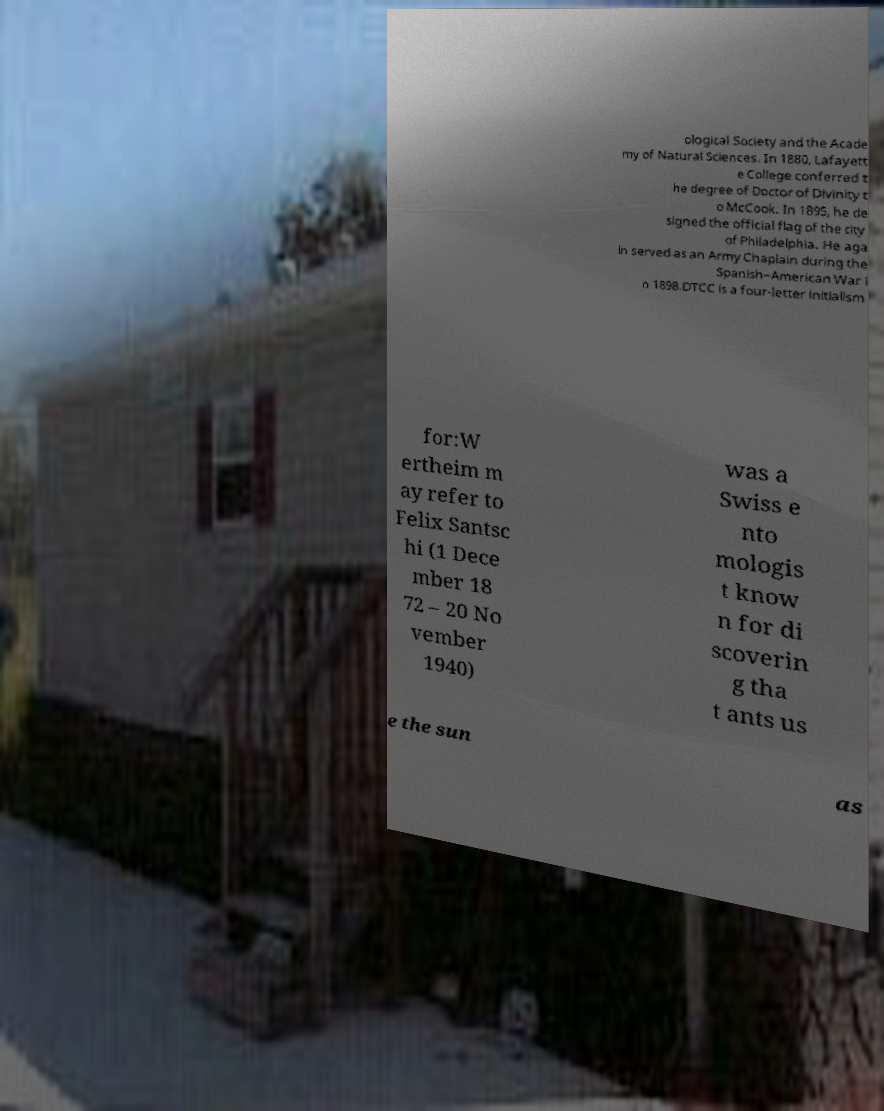Can you read and provide the text displayed in the image?This photo seems to have some interesting text. Can you extract and type it out for me? ological Society and the Acade my of Natural Sciences. In 1880, Lafayett e College conferred t he degree of Doctor of Divinity t o McCook. In 1895, he de signed the official flag of the city of Philadelphia. He aga in served as an Army Chaplain during the Spanish–American War i n 1898.DTCC is a four-letter initialism for:W ertheim m ay refer to Felix Santsc hi (1 Dece mber 18 72 – 20 No vember 1940) was a Swiss e nto mologis t know n for di scoverin g tha t ants us e the sun as 